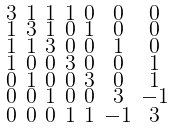<formula> <loc_0><loc_0><loc_500><loc_500>\begin{smallmatrix} 3 & 1 & 1 & 1 & 0 & 0 & 0 \\ 1 & 3 & 1 & 0 & 1 & 0 & 0 \\ 1 & 1 & 3 & 0 & 0 & 1 & 0 \\ 1 & 0 & 0 & 3 & 0 & 0 & 1 \\ 0 & 1 & 0 & 0 & 3 & 0 & 1 \\ 0 & 0 & 1 & 0 & 0 & 3 & - 1 \\ 0 & 0 & 0 & 1 & 1 & - 1 & 3 \end{smallmatrix}</formula> 